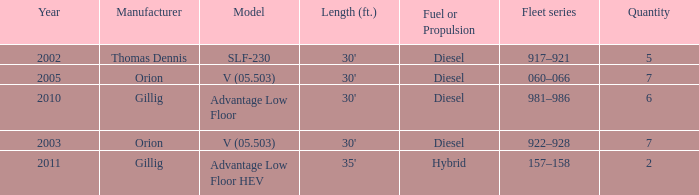Name the fleet series with a quantity of 5 917–921. 